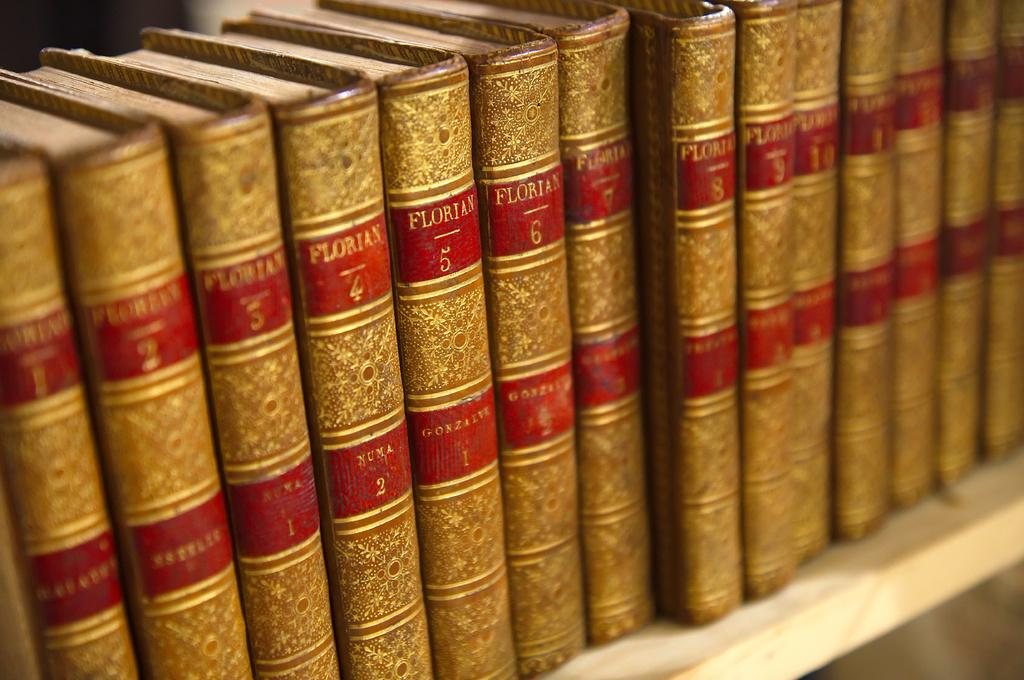<image>
Render a clear and concise summary of the photo. 14 volumes of Florian books sits on a shelf. 